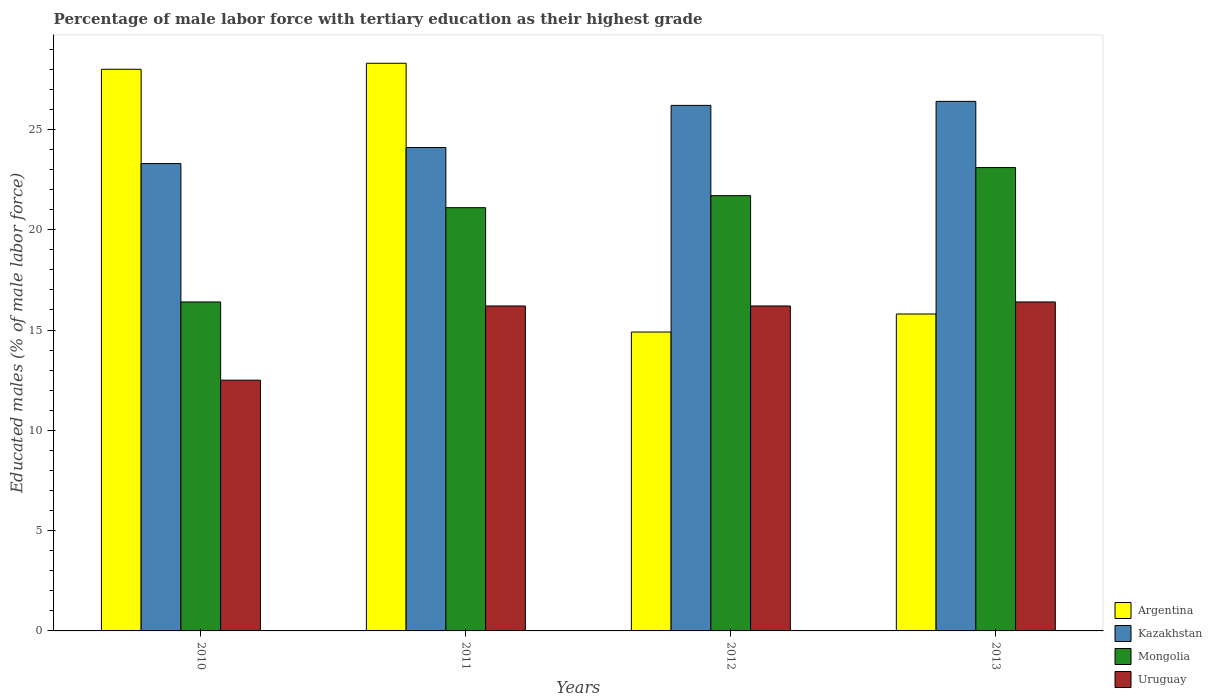How many groups of bars are there?
Keep it short and to the point. 4. Are the number of bars per tick equal to the number of legend labels?
Provide a short and direct response. Yes. What is the label of the 4th group of bars from the left?
Give a very brief answer. 2013. In how many cases, is the number of bars for a given year not equal to the number of legend labels?
Give a very brief answer. 0. What is the percentage of male labor force with tertiary education in Mongolia in 2011?
Keep it short and to the point. 21.1. Across all years, what is the maximum percentage of male labor force with tertiary education in Kazakhstan?
Your response must be concise. 26.4. Across all years, what is the minimum percentage of male labor force with tertiary education in Kazakhstan?
Offer a very short reply. 23.3. In which year was the percentage of male labor force with tertiary education in Kazakhstan maximum?
Provide a succinct answer. 2013. What is the total percentage of male labor force with tertiary education in Mongolia in the graph?
Offer a terse response. 82.3. What is the difference between the percentage of male labor force with tertiary education in Mongolia in 2012 and that in 2013?
Your answer should be very brief. -1.4. What is the difference between the percentage of male labor force with tertiary education in Uruguay in 2011 and the percentage of male labor force with tertiary education in Argentina in 2010?
Provide a short and direct response. -11.8. What is the average percentage of male labor force with tertiary education in Uruguay per year?
Ensure brevity in your answer.  15.33. In the year 2011, what is the difference between the percentage of male labor force with tertiary education in Uruguay and percentage of male labor force with tertiary education in Kazakhstan?
Make the answer very short. -7.9. What is the ratio of the percentage of male labor force with tertiary education in Uruguay in 2012 to that in 2013?
Give a very brief answer. 0.99. Is the percentage of male labor force with tertiary education in Kazakhstan in 2010 less than that in 2011?
Ensure brevity in your answer.  Yes. What is the difference between the highest and the second highest percentage of male labor force with tertiary education in Argentina?
Your response must be concise. 0.3. What is the difference between the highest and the lowest percentage of male labor force with tertiary education in Argentina?
Offer a very short reply. 13.4. In how many years, is the percentage of male labor force with tertiary education in Kazakhstan greater than the average percentage of male labor force with tertiary education in Kazakhstan taken over all years?
Provide a succinct answer. 2. Is the sum of the percentage of male labor force with tertiary education in Argentina in 2011 and 2013 greater than the maximum percentage of male labor force with tertiary education in Kazakhstan across all years?
Offer a terse response. Yes. What does the 1st bar from the left in 2010 represents?
Make the answer very short. Argentina. What does the 3rd bar from the right in 2011 represents?
Offer a very short reply. Kazakhstan. Is it the case that in every year, the sum of the percentage of male labor force with tertiary education in Argentina and percentage of male labor force with tertiary education in Uruguay is greater than the percentage of male labor force with tertiary education in Kazakhstan?
Give a very brief answer. Yes. What is the difference between two consecutive major ticks on the Y-axis?
Give a very brief answer. 5. Are the values on the major ticks of Y-axis written in scientific E-notation?
Provide a succinct answer. No. Does the graph contain any zero values?
Give a very brief answer. No. Does the graph contain grids?
Keep it short and to the point. No. Where does the legend appear in the graph?
Your response must be concise. Bottom right. How many legend labels are there?
Ensure brevity in your answer.  4. How are the legend labels stacked?
Offer a terse response. Vertical. What is the title of the graph?
Offer a very short reply. Percentage of male labor force with tertiary education as their highest grade. Does "Botswana" appear as one of the legend labels in the graph?
Your response must be concise. No. What is the label or title of the X-axis?
Ensure brevity in your answer.  Years. What is the label or title of the Y-axis?
Provide a succinct answer. Educated males (% of male labor force). What is the Educated males (% of male labor force) in Kazakhstan in 2010?
Keep it short and to the point. 23.3. What is the Educated males (% of male labor force) in Mongolia in 2010?
Ensure brevity in your answer.  16.4. What is the Educated males (% of male labor force) of Argentina in 2011?
Your response must be concise. 28.3. What is the Educated males (% of male labor force) of Kazakhstan in 2011?
Provide a short and direct response. 24.1. What is the Educated males (% of male labor force) of Mongolia in 2011?
Ensure brevity in your answer.  21.1. What is the Educated males (% of male labor force) of Uruguay in 2011?
Keep it short and to the point. 16.2. What is the Educated males (% of male labor force) in Argentina in 2012?
Keep it short and to the point. 14.9. What is the Educated males (% of male labor force) in Kazakhstan in 2012?
Your answer should be very brief. 26.2. What is the Educated males (% of male labor force) of Mongolia in 2012?
Keep it short and to the point. 21.7. What is the Educated males (% of male labor force) of Uruguay in 2012?
Provide a succinct answer. 16.2. What is the Educated males (% of male labor force) in Argentina in 2013?
Provide a short and direct response. 15.8. What is the Educated males (% of male labor force) of Kazakhstan in 2013?
Ensure brevity in your answer.  26.4. What is the Educated males (% of male labor force) of Mongolia in 2013?
Make the answer very short. 23.1. What is the Educated males (% of male labor force) in Uruguay in 2013?
Your answer should be very brief. 16.4. Across all years, what is the maximum Educated males (% of male labor force) in Argentina?
Provide a short and direct response. 28.3. Across all years, what is the maximum Educated males (% of male labor force) of Kazakhstan?
Give a very brief answer. 26.4. Across all years, what is the maximum Educated males (% of male labor force) in Mongolia?
Offer a terse response. 23.1. Across all years, what is the maximum Educated males (% of male labor force) of Uruguay?
Ensure brevity in your answer.  16.4. Across all years, what is the minimum Educated males (% of male labor force) of Argentina?
Provide a succinct answer. 14.9. Across all years, what is the minimum Educated males (% of male labor force) of Kazakhstan?
Ensure brevity in your answer.  23.3. Across all years, what is the minimum Educated males (% of male labor force) in Mongolia?
Offer a very short reply. 16.4. Across all years, what is the minimum Educated males (% of male labor force) of Uruguay?
Your answer should be compact. 12.5. What is the total Educated males (% of male labor force) of Mongolia in the graph?
Make the answer very short. 82.3. What is the total Educated males (% of male labor force) in Uruguay in the graph?
Provide a succinct answer. 61.3. What is the difference between the Educated males (% of male labor force) of Mongolia in 2010 and that in 2011?
Your answer should be very brief. -4.7. What is the difference between the Educated males (% of male labor force) of Uruguay in 2010 and that in 2011?
Your answer should be compact. -3.7. What is the difference between the Educated males (% of male labor force) in Kazakhstan in 2010 and that in 2012?
Ensure brevity in your answer.  -2.9. What is the difference between the Educated males (% of male labor force) in Mongolia in 2010 and that in 2012?
Your answer should be very brief. -5.3. What is the difference between the Educated males (% of male labor force) of Argentina in 2010 and that in 2013?
Provide a short and direct response. 12.2. What is the difference between the Educated males (% of male labor force) of Mongolia in 2010 and that in 2013?
Provide a succinct answer. -6.7. What is the difference between the Educated males (% of male labor force) of Uruguay in 2010 and that in 2013?
Provide a short and direct response. -3.9. What is the difference between the Educated males (% of male labor force) of Kazakhstan in 2011 and that in 2012?
Offer a very short reply. -2.1. What is the difference between the Educated males (% of male labor force) of Mongolia in 2011 and that in 2012?
Your answer should be very brief. -0.6. What is the difference between the Educated males (% of male labor force) of Uruguay in 2011 and that in 2012?
Make the answer very short. 0. What is the difference between the Educated males (% of male labor force) of Mongolia in 2011 and that in 2013?
Ensure brevity in your answer.  -2. What is the difference between the Educated males (% of male labor force) of Uruguay in 2011 and that in 2013?
Ensure brevity in your answer.  -0.2. What is the difference between the Educated males (% of male labor force) in Argentina in 2012 and that in 2013?
Ensure brevity in your answer.  -0.9. What is the difference between the Educated males (% of male labor force) of Kazakhstan in 2012 and that in 2013?
Ensure brevity in your answer.  -0.2. What is the difference between the Educated males (% of male labor force) in Mongolia in 2012 and that in 2013?
Provide a succinct answer. -1.4. What is the difference between the Educated males (% of male labor force) in Argentina in 2010 and the Educated males (% of male labor force) in Mongolia in 2011?
Give a very brief answer. 6.9. What is the difference between the Educated males (% of male labor force) in Kazakhstan in 2010 and the Educated males (% of male labor force) in Uruguay in 2011?
Your answer should be very brief. 7.1. What is the difference between the Educated males (% of male labor force) of Mongolia in 2010 and the Educated males (% of male labor force) of Uruguay in 2011?
Offer a very short reply. 0.2. What is the difference between the Educated males (% of male labor force) in Argentina in 2010 and the Educated males (% of male labor force) in Kazakhstan in 2012?
Make the answer very short. 1.8. What is the difference between the Educated males (% of male labor force) of Kazakhstan in 2010 and the Educated males (% of male labor force) of Uruguay in 2012?
Make the answer very short. 7.1. What is the difference between the Educated males (% of male labor force) in Mongolia in 2010 and the Educated males (% of male labor force) in Uruguay in 2012?
Provide a short and direct response. 0.2. What is the difference between the Educated males (% of male labor force) of Argentina in 2010 and the Educated males (% of male labor force) of Kazakhstan in 2013?
Ensure brevity in your answer.  1.6. What is the difference between the Educated males (% of male labor force) of Argentina in 2010 and the Educated males (% of male labor force) of Mongolia in 2013?
Your answer should be compact. 4.9. What is the difference between the Educated males (% of male labor force) in Kazakhstan in 2010 and the Educated males (% of male labor force) in Mongolia in 2013?
Give a very brief answer. 0.2. What is the difference between the Educated males (% of male labor force) of Kazakhstan in 2010 and the Educated males (% of male labor force) of Uruguay in 2013?
Give a very brief answer. 6.9. What is the difference between the Educated males (% of male labor force) in Mongolia in 2010 and the Educated males (% of male labor force) in Uruguay in 2013?
Offer a terse response. 0. What is the difference between the Educated males (% of male labor force) of Argentina in 2011 and the Educated males (% of male labor force) of Uruguay in 2012?
Provide a succinct answer. 12.1. What is the difference between the Educated males (% of male labor force) of Kazakhstan in 2011 and the Educated males (% of male labor force) of Mongolia in 2012?
Provide a succinct answer. 2.4. What is the difference between the Educated males (% of male labor force) in Kazakhstan in 2011 and the Educated males (% of male labor force) in Uruguay in 2012?
Keep it short and to the point. 7.9. What is the difference between the Educated males (% of male labor force) in Mongolia in 2011 and the Educated males (% of male labor force) in Uruguay in 2012?
Give a very brief answer. 4.9. What is the difference between the Educated males (% of male labor force) in Argentina in 2011 and the Educated males (% of male labor force) in Mongolia in 2013?
Ensure brevity in your answer.  5.2. What is the difference between the Educated males (% of male labor force) of Argentina in 2011 and the Educated males (% of male labor force) of Uruguay in 2013?
Provide a succinct answer. 11.9. What is the difference between the Educated males (% of male labor force) in Kazakhstan in 2011 and the Educated males (% of male labor force) in Mongolia in 2013?
Ensure brevity in your answer.  1. What is the difference between the Educated males (% of male labor force) in Kazakhstan in 2011 and the Educated males (% of male labor force) in Uruguay in 2013?
Your answer should be compact. 7.7. What is the difference between the Educated males (% of male labor force) of Argentina in 2012 and the Educated males (% of male labor force) of Kazakhstan in 2013?
Give a very brief answer. -11.5. What is the difference between the Educated males (% of male labor force) of Argentina in 2012 and the Educated males (% of male labor force) of Mongolia in 2013?
Ensure brevity in your answer.  -8.2. What is the average Educated males (% of male labor force) of Argentina per year?
Provide a succinct answer. 21.75. What is the average Educated males (% of male labor force) of Mongolia per year?
Keep it short and to the point. 20.57. What is the average Educated males (% of male labor force) in Uruguay per year?
Your response must be concise. 15.32. In the year 2010, what is the difference between the Educated males (% of male labor force) of Argentina and Educated males (% of male labor force) of Mongolia?
Your answer should be compact. 11.6. In the year 2010, what is the difference between the Educated males (% of male labor force) of Kazakhstan and Educated males (% of male labor force) of Mongolia?
Give a very brief answer. 6.9. In the year 2010, what is the difference between the Educated males (% of male labor force) of Kazakhstan and Educated males (% of male labor force) of Uruguay?
Ensure brevity in your answer.  10.8. In the year 2010, what is the difference between the Educated males (% of male labor force) in Mongolia and Educated males (% of male labor force) in Uruguay?
Your answer should be compact. 3.9. In the year 2011, what is the difference between the Educated males (% of male labor force) in Argentina and Educated males (% of male labor force) in Uruguay?
Offer a very short reply. 12.1. In the year 2011, what is the difference between the Educated males (% of male labor force) in Kazakhstan and Educated males (% of male labor force) in Mongolia?
Keep it short and to the point. 3. In the year 2011, what is the difference between the Educated males (% of male labor force) in Kazakhstan and Educated males (% of male labor force) in Uruguay?
Your answer should be compact. 7.9. In the year 2011, what is the difference between the Educated males (% of male labor force) in Mongolia and Educated males (% of male labor force) in Uruguay?
Offer a terse response. 4.9. In the year 2012, what is the difference between the Educated males (% of male labor force) in Argentina and Educated males (% of male labor force) in Uruguay?
Provide a succinct answer. -1.3. In the year 2012, what is the difference between the Educated males (% of male labor force) of Kazakhstan and Educated males (% of male labor force) of Mongolia?
Provide a short and direct response. 4.5. In the year 2012, what is the difference between the Educated males (% of male labor force) of Kazakhstan and Educated males (% of male labor force) of Uruguay?
Your response must be concise. 10. In the year 2012, what is the difference between the Educated males (% of male labor force) in Mongolia and Educated males (% of male labor force) in Uruguay?
Offer a terse response. 5.5. In the year 2013, what is the difference between the Educated males (% of male labor force) in Argentina and Educated males (% of male labor force) in Kazakhstan?
Keep it short and to the point. -10.6. In the year 2013, what is the difference between the Educated males (% of male labor force) in Argentina and Educated males (% of male labor force) in Uruguay?
Provide a short and direct response. -0.6. In the year 2013, what is the difference between the Educated males (% of male labor force) in Kazakhstan and Educated males (% of male labor force) in Mongolia?
Ensure brevity in your answer.  3.3. In the year 2013, what is the difference between the Educated males (% of male labor force) in Mongolia and Educated males (% of male labor force) in Uruguay?
Make the answer very short. 6.7. What is the ratio of the Educated males (% of male labor force) of Kazakhstan in 2010 to that in 2011?
Ensure brevity in your answer.  0.97. What is the ratio of the Educated males (% of male labor force) in Mongolia in 2010 to that in 2011?
Offer a very short reply. 0.78. What is the ratio of the Educated males (% of male labor force) of Uruguay in 2010 to that in 2011?
Offer a terse response. 0.77. What is the ratio of the Educated males (% of male labor force) in Argentina in 2010 to that in 2012?
Your answer should be very brief. 1.88. What is the ratio of the Educated males (% of male labor force) of Kazakhstan in 2010 to that in 2012?
Give a very brief answer. 0.89. What is the ratio of the Educated males (% of male labor force) in Mongolia in 2010 to that in 2012?
Keep it short and to the point. 0.76. What is the ratio of the Educated males (% of male labor force) in Uruguay in 2010 to that in 2012?
Your response must be concise. 0.77. What is the ratio of the Educated males (% of male labor force) of Argentina in 2010 to that in 2013?
Your answer should be compact. 1.77. What is the ratio of the Educated males (% of male labor force) of Kazakhstan in 2010 to that in 2013?
Your response must be concise. 0.88. What is the ratio of the Educated males (% of male labor force) of Mongolia in 2010 to that in 2013?
Offer a very short reply. 0.71. What is the ratio of the Educated males (% of male labor force) of Uruguay in 2010 to that in 2013?
Provide a short and direct response. 0.76. What is the ratio of the Educated males (% of male labor force) of Argentina in 2011 to that in 2012?
Keep it short and to the point. 1.9. What is the ratio of the Educated males (% of male labor force) in Kazakhstan in 2011 to that in 2012?
Offer a very short reply. 0.92. What is the ratio of the Educated males (% of male labor force) in Mongolia in 2011 to that in 2012?
Keep it short and to the point. 0.97. What is the ratio of the Educated males (% of male labor force) of Uruguay in 2011 to that in 2012?
Make the answer very short. 1. What is the ratio of the Educated males (% of male labor force) of Argentina in 2011 to that in 2013?
Offer a very short reply. 1.79. What is the ratio of the Educated males (% of male labor force) of Kazakhstan in 2011 to that in 2013?
Offer a terse response. 0.91. What is the ratio of the Educated males (% of male labor force) in Mongolia in 2011 to that in 2013?
Give a very brief answer. 0.91. What is the ratio of the Educated males (% of male labor force) of Argentina in 2012 to that in 2013?
Your answer should be very brief. 0.94. What is the ratio of the Educated males (% of male labor force) in Mongolia in 2012 to that in 2013?
Provide a short and direct response. 0.94. What is the difference between the highest and the second highest Educated males (% of male labor force) in Argentina?
Your answer should be very brief. 0.3. What is the difference between the highest and the second highest Educated males (% of male labor force) in Mongolia?
Make the answer very short. 1.4. What is the difference between the highest and the lowest Educated males (% of male labor force) in Mongolia?
Provide a succinct answer. 6.7. 